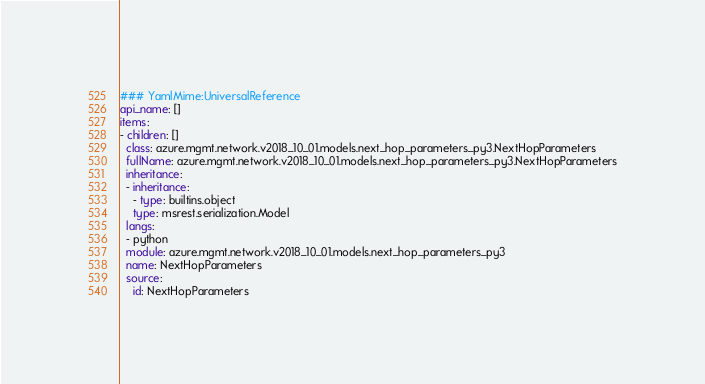<code> <loc_0><loc_0><loc_500><loc_500><_YAML_>### YamlMime:UniversalReference
api_name: []
items:
- children: []
  class: azure.mgmt.network.v2018_10_01.models.next_hop_parameters_py3.NextHopParameters
  fullName: azure.mgmt.network.v2018_10_01.models.next_hop_parameters_py3.NextHopParameters
  inheritance:
  - inheritance:
    - type: builtins.object
    type: msrest.serialization.Model
  langs:
  - python
  module: azure.mgmt.network.v2018_10_01.models.next_hop_parameters_py3
  name: NextHopParameters
  source:
    id: NextHopParameters</code> 